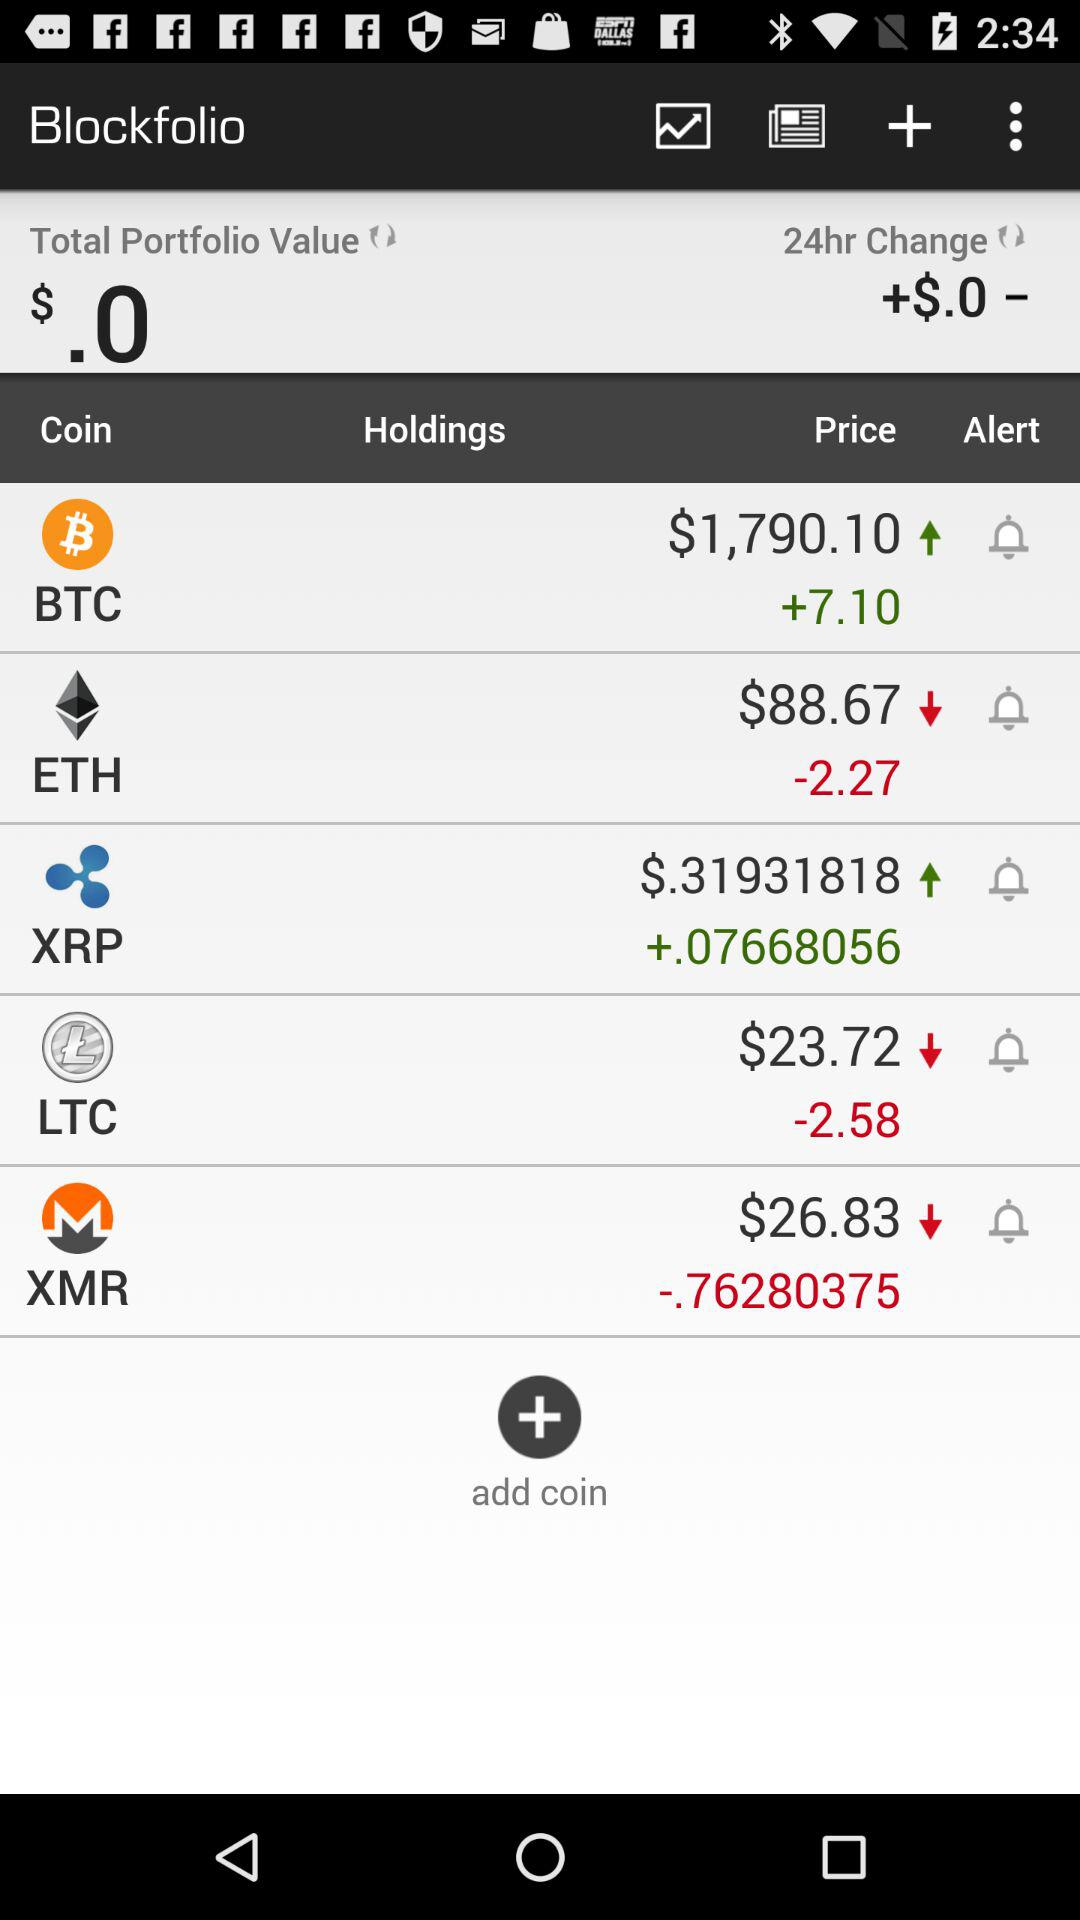What is the current value of XMR? The current value of XMR is $26.83. 